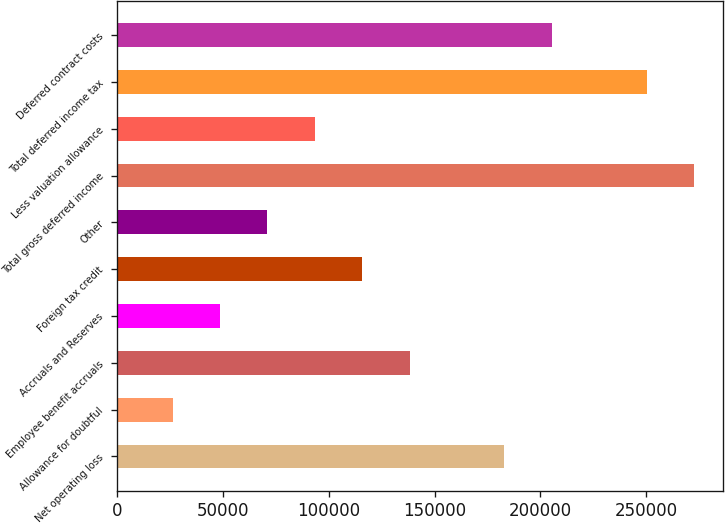<chart> <loc_0><loc_0><loc_500><loc_500><bar_chart><fcel>Net operating loss<fcel>Allowance for doubtful<fcel>Employee benefit accruals<fcel>Accruals and Reserves<fcel>Foreign tax credit<fcel>Other<fcel>Total gross deferred income<fcel>Less valuation allowance<fcel>Total deferred income tax<fcel>Deferred contract costs<nl><fcel>183000<fcel>26154.5<fcel>138187<fcel>48561<fcel>115780<fcel>70967.5<fcel>272626<fcel>93374<fcel>250220<fcel>205406<nl></chart> 